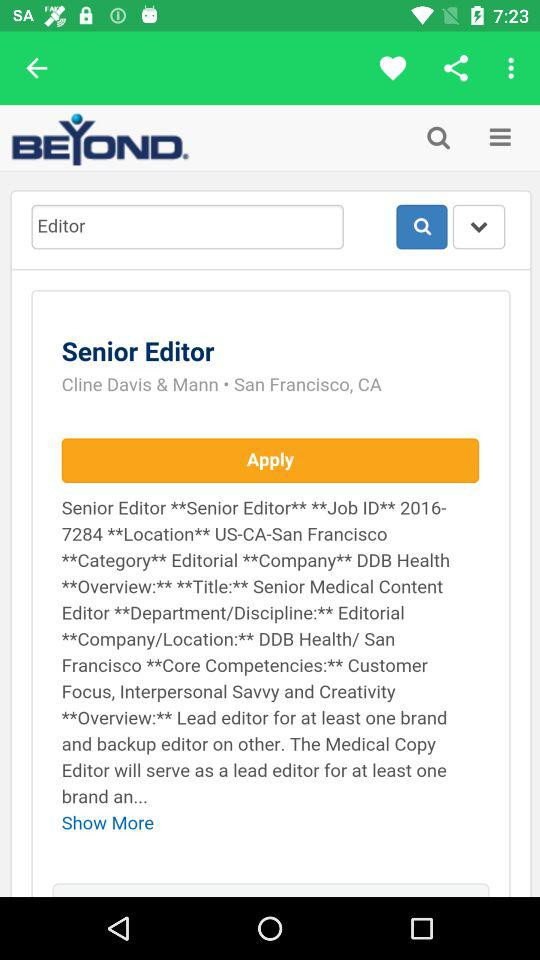What is the text in the input field? The text in the input field is "Editor". 